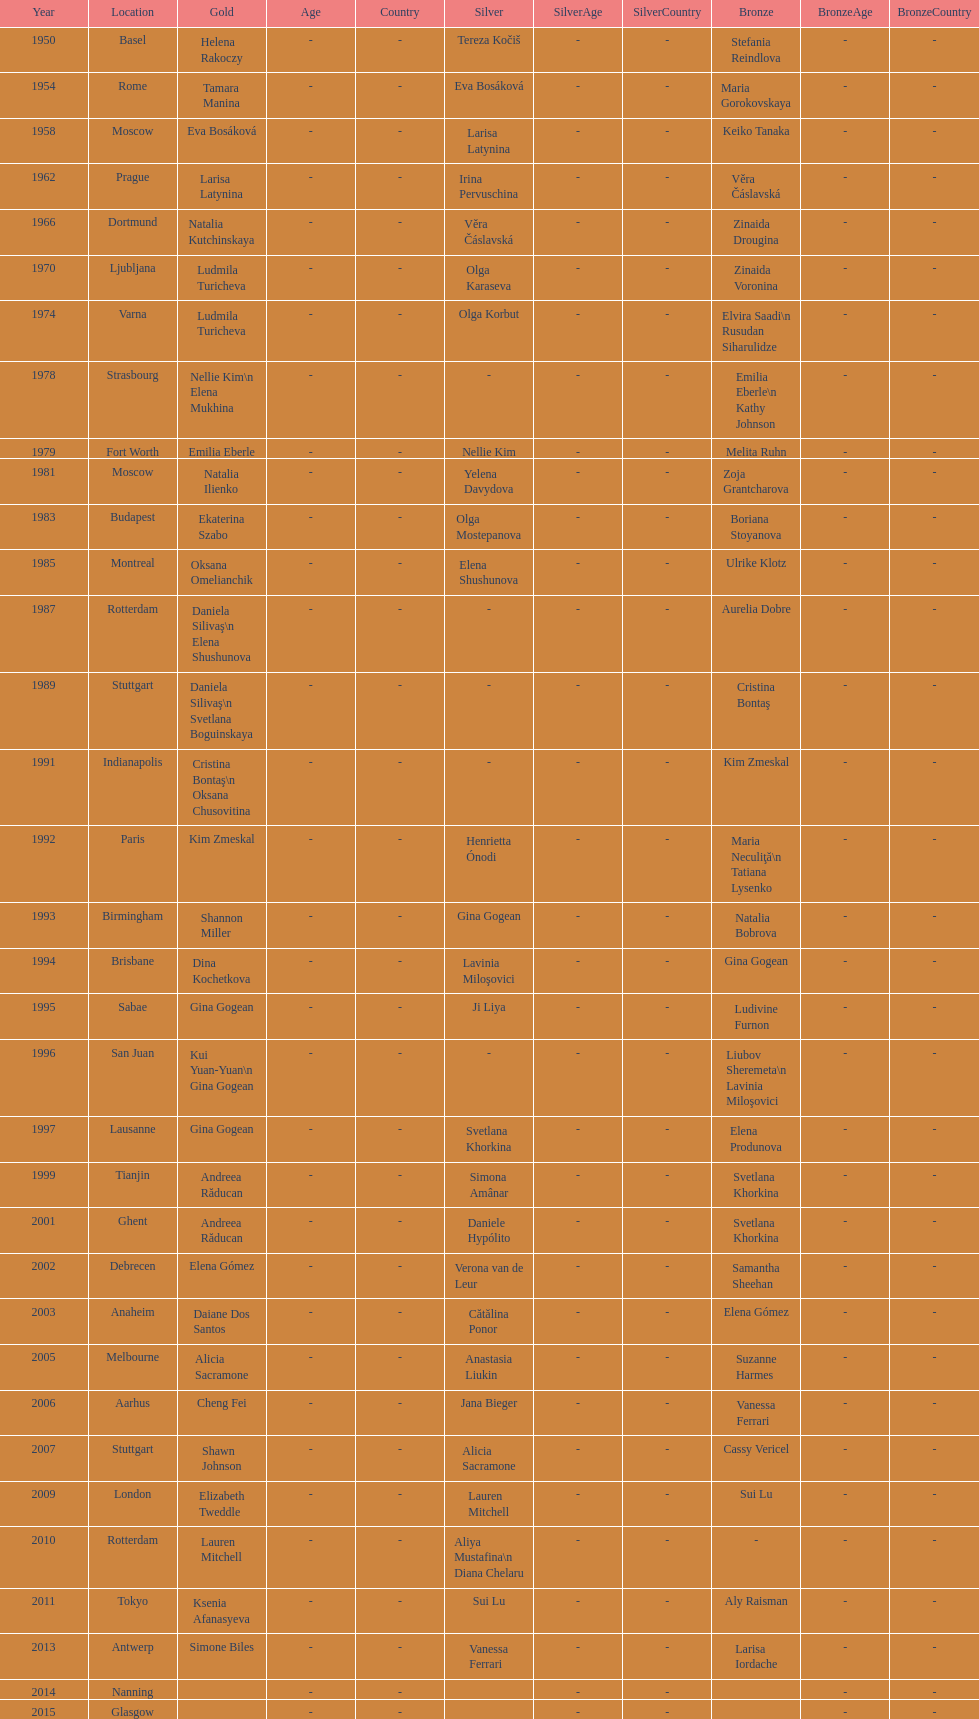What is the interval between the championships that occurred in moscow? 23 years. 